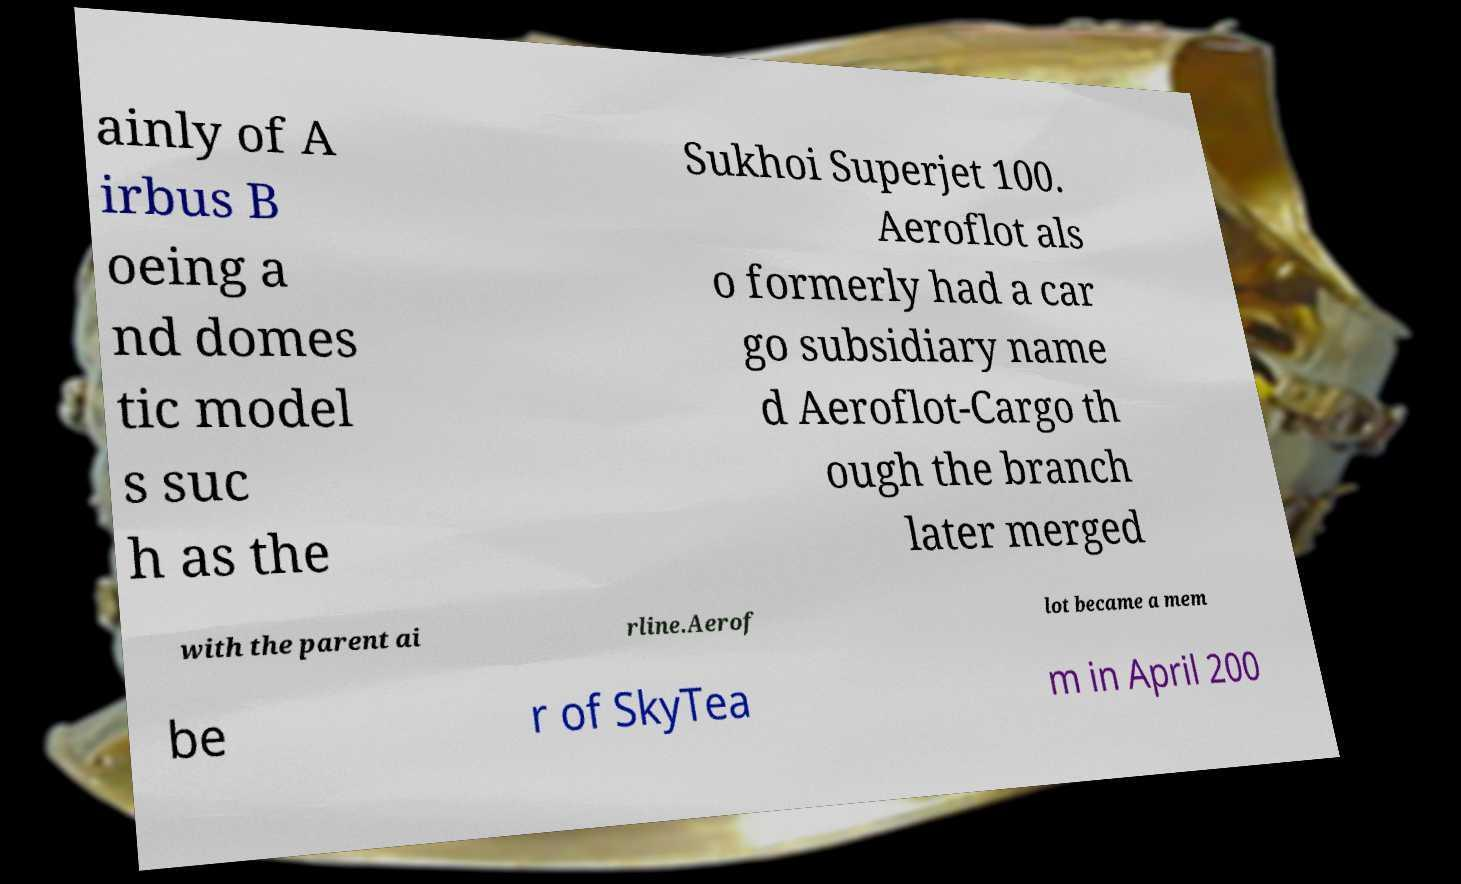Could you assist in decoding the text presented in this image and type it out clearly? ainly of A irbus B oeing a nd domes tic model s suc h as the Sukhoi Superjet 100. Aeroflot als o formerly had a car go subsidiary name d Aeroflot-Cargo th ough the branch later merged with the parent ai rline.Aerof lot became a mem be r of SkyTea m in April 200 